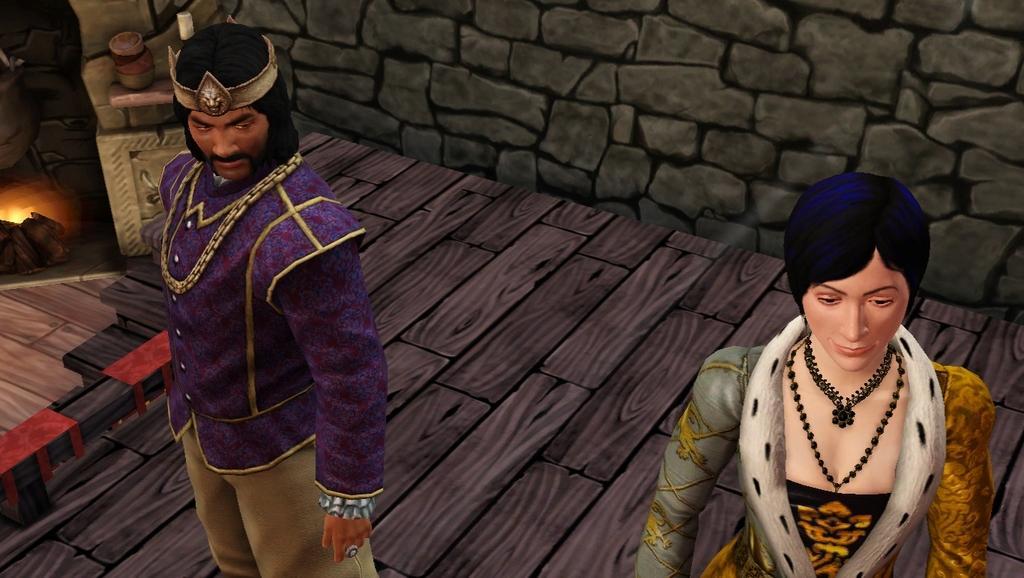How would you summarize this image in a sentence or two? In this image I can see the animated picture. In front the person is wearing yellow and white color dress and the person at left is wearing purple and cream color dress. Background I can see the fireplace and the wall is in black and grey color. 